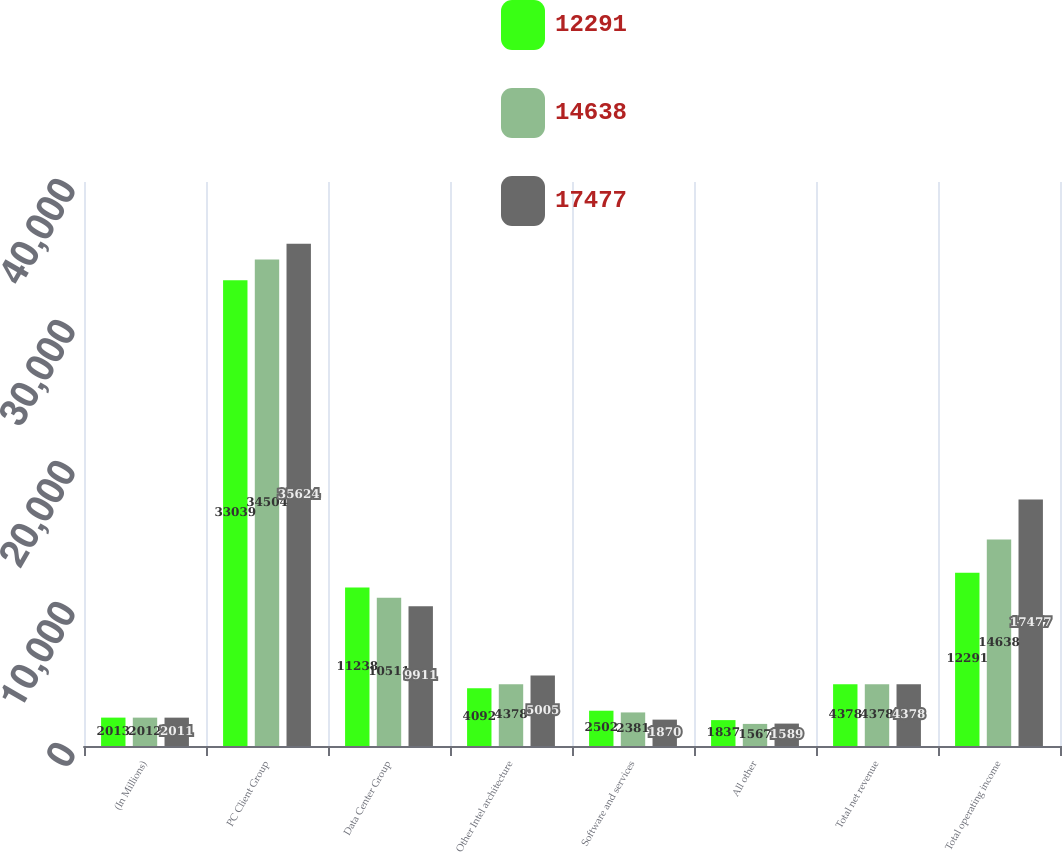<chart> <loc_0><loc_0><loc_500><loc_500><stacked_bar_chart><ecel><fcel>(In Millions)<fcel>PC Client Group<fcel>Data Center Group<fcel>Other Intel architecture<fcel>Software and services<fcel>All other<fcel>Total net revenue<fcel>Total operating income<nl><fcel>12291<fcel>2013<fcel>33039<fcel>11238<fcel>4092<fcel>2502<fcel>1837<fcel>4378<fcel>12291<nl><fcel>14638<fcel>2012<fcel>34504<fcel>10511<fcel>4378<fcel>2381<fcel>1567<fcel>4378<fcel>14638<nl><fcel>17477<fcel>2011<fcel>35624<fcel>9911<fcel>5005<fcel>1870<fcel>1589<fcel>4378<fcel>17477<nl></chart> 